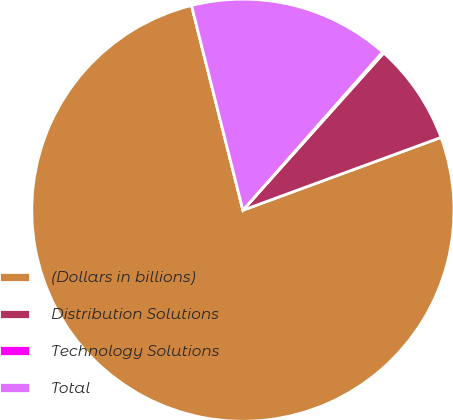Convert chart to OTSL. <chart><loc_0><loc_0><loc_500><loc_500><pie_chart><fcel>(Dollars in billions)<fcel>Distribution Solutions<fcel>Technology Solutions<fcel>Total<nl><fcel>76.69%<fcel>7.77%<fcel>0.11%<fcel>15.43%<nl></chart> 